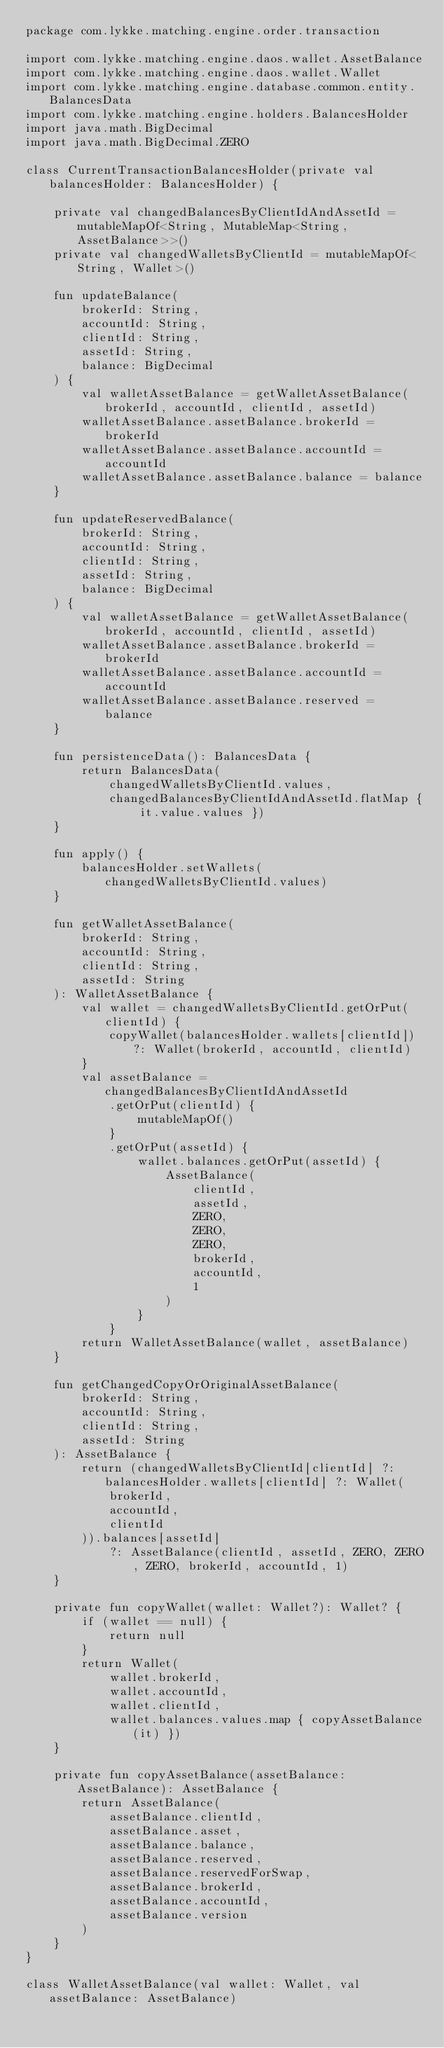<code> <loc_0><loc_0><loc_500><loc_500><_Kotlin_>package com.lykke.matching.engine.order.transaction

import com.lykke.matching.engine.daos.wallet.AssetBalance
import com.lykke.matching.engine.daos.wallet.Wallet
import com.lykke.matching.engine.database.common.entity.BalancesData
import com.lykke.matching.engine.holders.BalancesHolder
import java.math.BigDecimal
import java.math.BigDecimal.ZERO

class CurrentTransactionBalancesHolder(private val balancesHolder: BalancesHolder) {

    private val changedBalancesByClientIdAndAssetId = mutableMapOf<String, MutableMap<String, AssetBalance>>()
    private val changedWalletsByClientId = mutableMapOf<String, Wallet>()

    fun updateBalance(
        brokerId: String,
        accountId: String,
        clientId: String,
        assetId: String,
        balance: BigDecimal
    ) {
        val walletAssetBalance = getWalletAssetBalance(brokerId, accountId, clientId, assetId)
        walletAssetBalance.assetBalance.brokerId = brokerId
        walletAssetBalance.assetBalance.accountId = accountId
        walletAssetBalance.assetBalance.balance = balance
    }

    fun updateReservedBalance(
        brokerId: String,
        accountId: String,
        clientId: String,
        assetId: String,
        balance: BigDecimal
    ) {
        val walletAssetBalance = getWalletAssetBalance(brokerId, accountId, clientId, assetId)
        walletAssetBalance.assetBalance.brokerId = brokerId
        walletAssetBalance.assetBalance.accountId = accountId
        walletAssetBalance.assetBalance.reserved = balance
    }

    fun persistenceData(): BalancesData {
        return BalancesData(
            changedWalletsByClientId.values,
            changedBalancesByClientIdAndAssetId.flatMap { it.value.values })
    }

    fun apply() {
        balancesHolder.setWallets(changedWalletsByClientId.values)
    }

    fun getWalletAssetBalance(
        brokerId: String,
        accountId: String,
        clientId: String,
        assetId: String
    ): WalletAssetBalance {
        val wallet = changedWalletsByClientId.getOrPut(clientId) {
            copyWallet(balancesHolder.wallets[clientId]) ?: Wallet(brokerId, accountId, clientId)
        }
        val assetBalance = changedBalancesByClientIdAndAssetId
            .getOrPut(clientId) {
                mutableMapOf()
            }
            .getOrPut(assetId) {
                wallet.balances.getOrPut(assetId) {
                    AssetBalance(
                        clientId,
                        assetId,
                        ZERO,
                        ZERO,
                        ZERO,
                        brokerId,
                        accountId,
                        1
                    )
                }
            }
        return WalletAssetBalance(wallet, assetBalance)
    }

    fun getChangedCopyOrOriginalAssetBalance(
        brokerId: String,
        accountId: String,
        clientId: String,
        assetId: String
    ): AssetBalance {
        return (changedWalletsByClientId[clientId] ?: balancesHolder.wallets[clientId] ?: Wallet(
            brokerId,
            accountId,
            clientId
        )).balances[assetId]
            ?: AssetBalance(clientId, assetId, ZERO, ZERO, ZERO, brokerId, accountId, 1)
    }

    private fun copyWallet(wallet: Wallet?): Wallet? {
        if (wallet == null) {
            return null
        }
        return Wallet(
            wallet.brokerId,
            wallet.accountId,
            wallet.clientId,
            wallet.balances.values.map { copyAssetBalance(it) })
    }

    private fun copyAssetBalance(assetBalance: AssetBalance): AssetBalance {
        return AssetBalance(
            assetBalance.clientId,
            assetBalance.asset,
            assetBalance.balance,
            assetBalance.reserved,
            assetBalance.reservedForSwap,
            assetBalance.brokerId,
            assetBalance.accountId,
            assetBalance.version
        )
    }
}

class WalletAssetBalance(val wallet: Wallet, val assetBalance: AssetBalance)</code> 